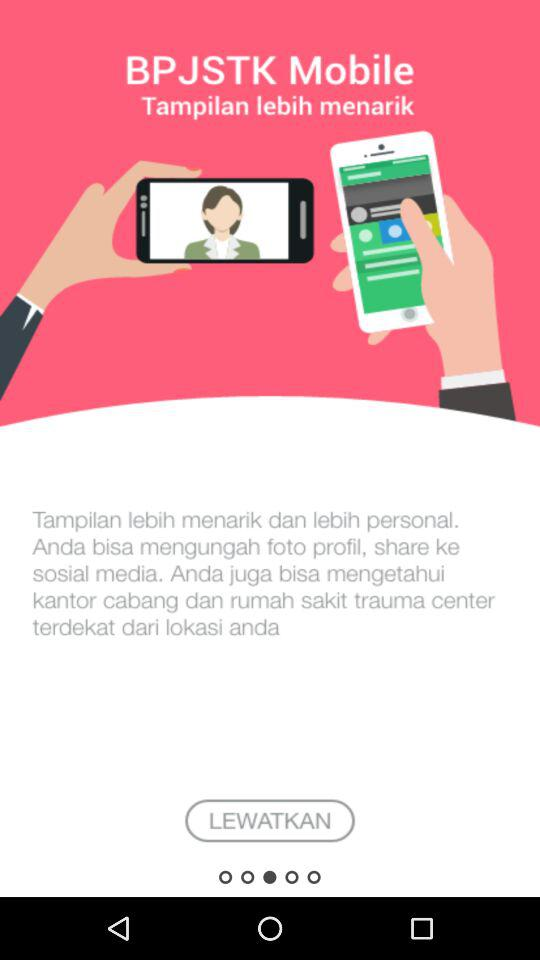What is the application name? The application name is "BPJSTK Mobile". 